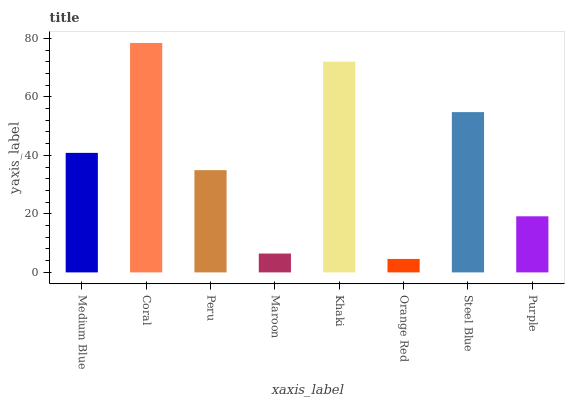Is Orange Red the minimum?
Answer yes or no. Yes. Is Coral the maximum?
Answer yes or no. Yes. Is Peru the minimum?
Answer yes or no. No. Is Peru the maximum?
Answer yes or no. No. Is Coral greater than Peru?
Answer yes or no. Yes. Is Peru less than Coral?
Answer yes or no. Yes. Is Peru greater than Coral?
Answer yes or no. No. Is Coral less than Peru?
Answer yes or no. No. Is Medium Blue the high median?
Answer yes or no. Yes. Is Peru the low median?
Answer yes or no. Yes. Is Steel Blue the high median?
Answer yes or no. No. Is Orange Red the low median?
Answer yes or no. No. 